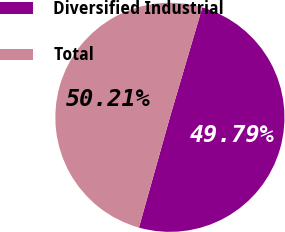Convert chart to OTSL. <chart><loc_0><loc_0><loc_500><loc_500><pie_chart><fcel>Diversified Industrial<fcel>Total<nl><fcel>49.79%<fcel>50.21%<nl></chart> 